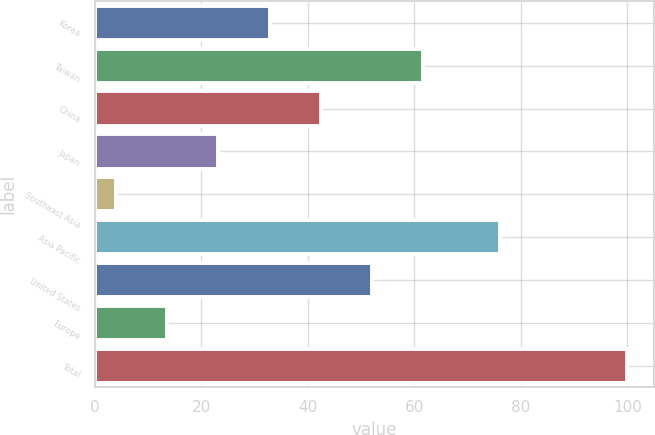Convert chart. <chart><loc_0><loc_0><loc_500><loc_500><bar_chart><fcel>Korea<fcel>Taiwan<fcel>China<fcel>Japan<fcel>Southeast Asia<fcel>Asia Pacific<fcel>United States<fcel>Europe<fcel>Total<nl><fcel>32.8<fcel>61.6<fcel>42.4<fcel>23.2<fcel>4<fcel>76<fcel>52<fcel>13.6<fcel>100<nl></chart> 